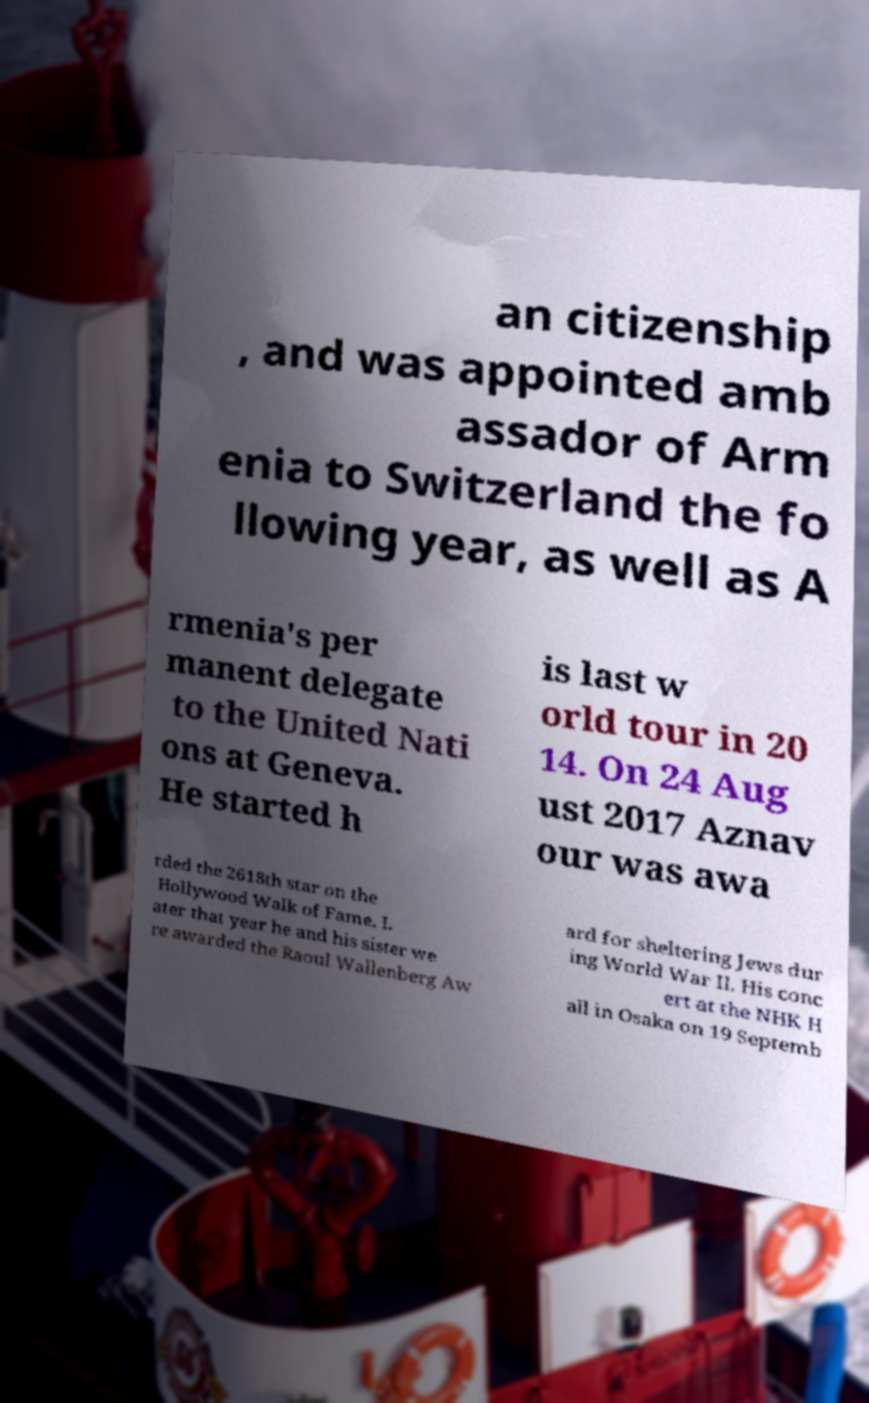There's text embedded in this image that I need extracted. Can you transcribe it verbatim? an citizenship , and was appointed amb assador of Arm enia to Switzerland the fo llowing year, as well as A rmenia's per manent delegate to the United Nati ons at Geneva. He started h is last w orld tour in 20 14. On 24 Aug ust 2017 Aznav our was awa rded the 2618th star on the Hollywood Walk of Fame. L ater that year he and his sister we re awarded the Raoul Wallenberg Aw ard for sheltering Jews dur ing World War II. His conc ert at the NHK H all in Osaka on 19 Septemb 